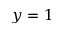<formula> <loc_0><loc_0><loc_500><loc_500>y = 1</formula> 